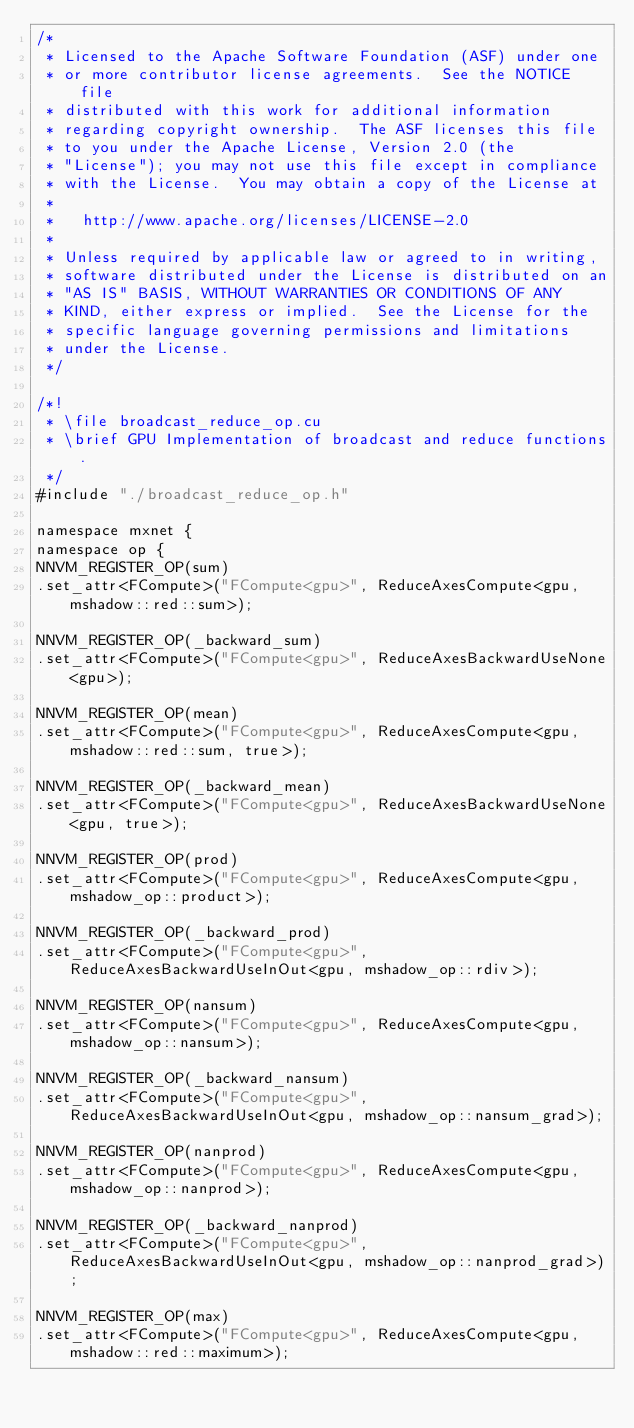Convert code to text. <code><loc_0><loc_0><loc_500><loc_500><_Cuda_>/*
 * Licensed to the Apache Software Foundation (ASF) under one
 * or more contributor license agreements.  See the NOTICE file
 * distributed with this work for additional information
 * regarding copyright ownership.  The ASF licenses this file
 * to you under the Apache License, Version 2.0 (the
 * "License"); you may not use this file except in compliance
 * with the License.  You may obtain a copy of the License at
 *
 *   http://www.apache.org/licenses/LICENSE-2.0
 *
 * Unless required by applicable law or agreed to in writing,
 * software distributed under the License is distributed on an
 * "AS IS" BASIS, WITHOUT WARRANTIES OR CONDITIONS OF ANY
 * KIND, either express or implied.  See the License for the
 * specific language governing permissions and limitations
 * under the License.
 */

/*!
 * \file broadcast_reduce_op.cu
 * \brief GPU Implementation of broadcast and reduce functions.
 */
#include "./broadcast_reduce_op.h"

namespace mxnet {
namespace op {
NNVM_REGISTER_OP(sum)
.set_attr<FCompute>("FCompute<gpu>", ReduceAxesCompute<gpu, mshadow::red::sum>);

NNVM_REGISTER_OP(_backward_sum)
.set_attr<FCompute>("FCompute<gpu>", ReduceAxesBackwardUseNone<gpu>);

NNVM_REGISTER_OP(mean)
.set_attr<FCompute>("FCompute<gpu>", ReduceAxesCompute<gpu, mshadow::red::sum, true>);

NNVM_REGISTER_OP(_backward_mean)
.set_attr<FCompute>("FCompute<gpu>", ReduceAxesBackwardUseNone<gpu, true>);

NNVM_REGISTER_OP(prod)
.set_attr<FCompute>("FCompute<gpu>", ReduceAxesCompute<gpu, mshadow_op::product>);

NNVM_REGISTER_OP(_backward_prod)
.set_attr<FCompute>("FCompute<gpu>", ReduceAxesBackwardUseInOut<gpu, mshadow_op::rdiv>);

NNVM_REGISTER_OP(nansum)
.set_attr<FCompute>("FCompute<gpu>", ReduceAxesCompute<gpu, mshadow_op::nansum>);

NNVM_REGISTER_OP(_backward_nansum)
.set_attr<FCompute>("FCompute<gpu>", ReduceAxesBackwardUseInOut<gpu, mshadow_op::nansum_grad>);

NNVM_REGISTER_OP(nanprod)
.set_attr<FCompute>("FCompute<gpu>", ReduceAxesCompute<gpu, mshadow_op::nanprod>);

NNVM_REGISTER_OP(_backward_nanprod)
.set_attr<FCompute>("FCompute<gpu>", ReduceAxesBackwardUseInOut<gpu, mshadow_op::nanprod_grad>);

NNVM_REGISTER_OP(max)
.set_attr<FCompute>("FCompute<gpu>", ReduceAxesCompute<gpu, mshadow::red::maximum>);
</code> 